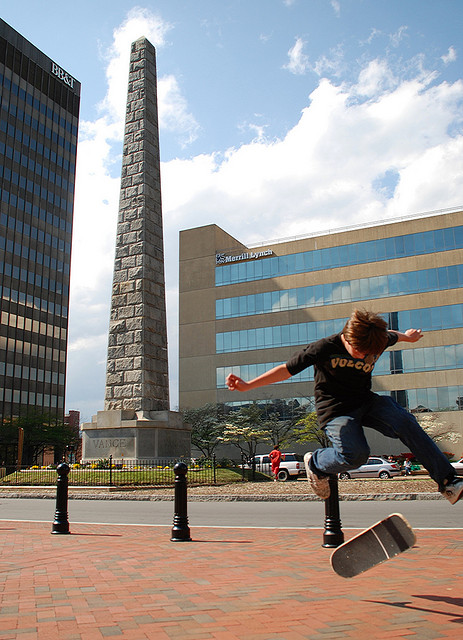Read all the text in this image. VOLCO LLynea 